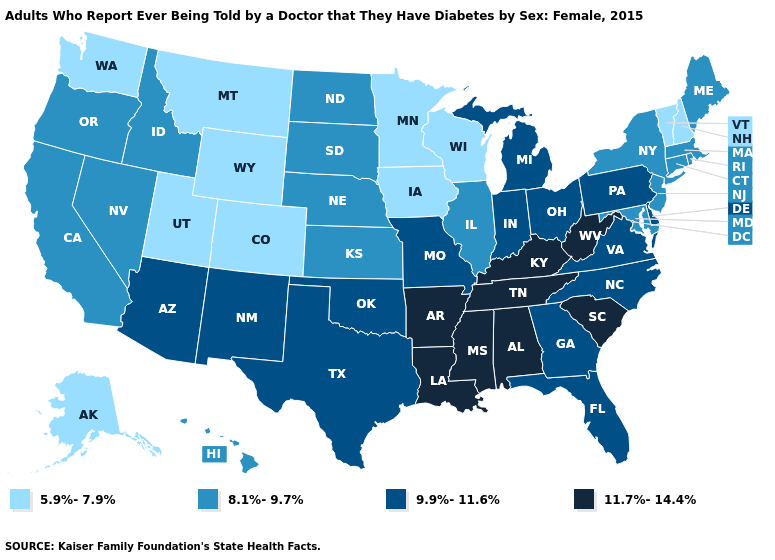Does Wisconsin have the lowest value in the USA?
Be succinct. Yes. What is the value of New Hampshire?
Write a very short answer. 5.9%-7.9%. Does the map have missing data?
Concise answer only. No. What is the lowest value in the USA?
Write a very short answer. 5.9%-7.9%. Among the states that border New Hampshire , does Maine have the lowest value?
Quick response, please. No. Among the states that border Arizona , does California have the lowest value?
Keep it brief. No. What is the value of Nebraska?
Keep it brief. 8.1%-9.7%. Does Virginia have the lowest value in the USA?
Write a very short answer. No. How many symbols are there in the legend?
Write a very short answer. 4. What is the value of Michigan?
Be succinct. 9.9%-11.6%. Among the states that border Nebraska , does Colorado have the lowest value?
Answer briefly. Yes. Name the states that have a value in the range 5.9%-7.9%?
Be succinct. Alaska, Colorado, Iowa, Minnesota, Montana, New Hampshire, Utah, Vermont, Washington, Wisconsin, Wyoming. Among the states that border Minnesota , does Iowa have the lowest value?
Short answer required. Yes. Which states have the lowest value in the South?
Quick response, please. Maryland. 